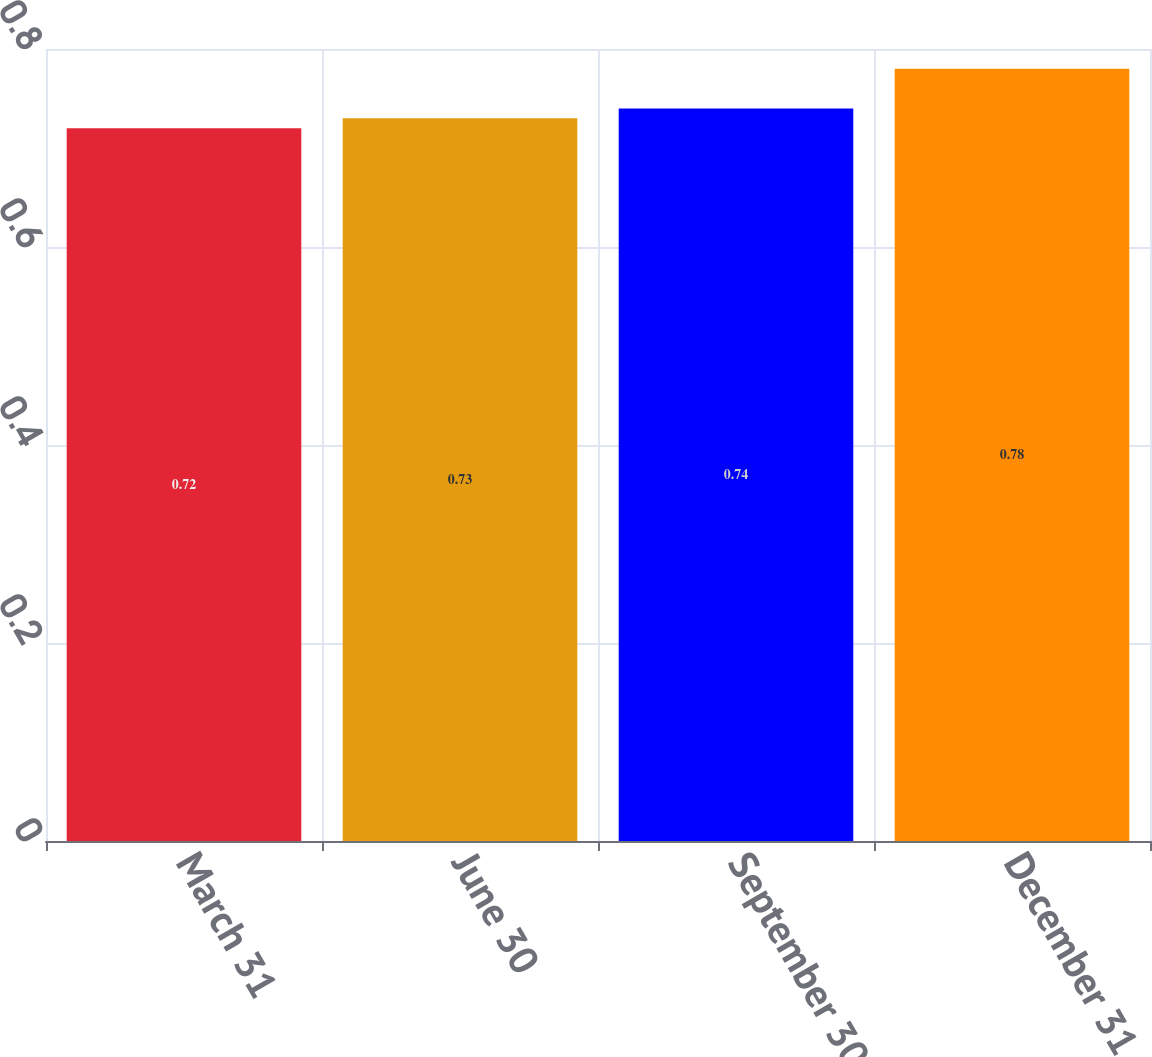Convert chart to OTSL. <chart><loc_0><loc_0><loc_500><loc_500><bar_chart><fcel>March 31<fcel>June 30<fcel>September 30<fcel>December 31<nl><fcel>0.72<fcel>0.73<fcel>0.74<fcel>0.78<nl></chart> 